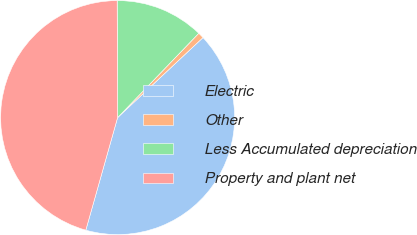Convert chart to OTSL. <chart><loc_0><loc_0><loc_500><loc_500><pie_chart><fcel>Electric<fcel>Other<fcel>Less Accumulated depreciation<fcel>Property and plant net<nl><fcel>41.36%<fcel>0.82%<fcel>12.26%<fcel>45.56%<nl></chart> 